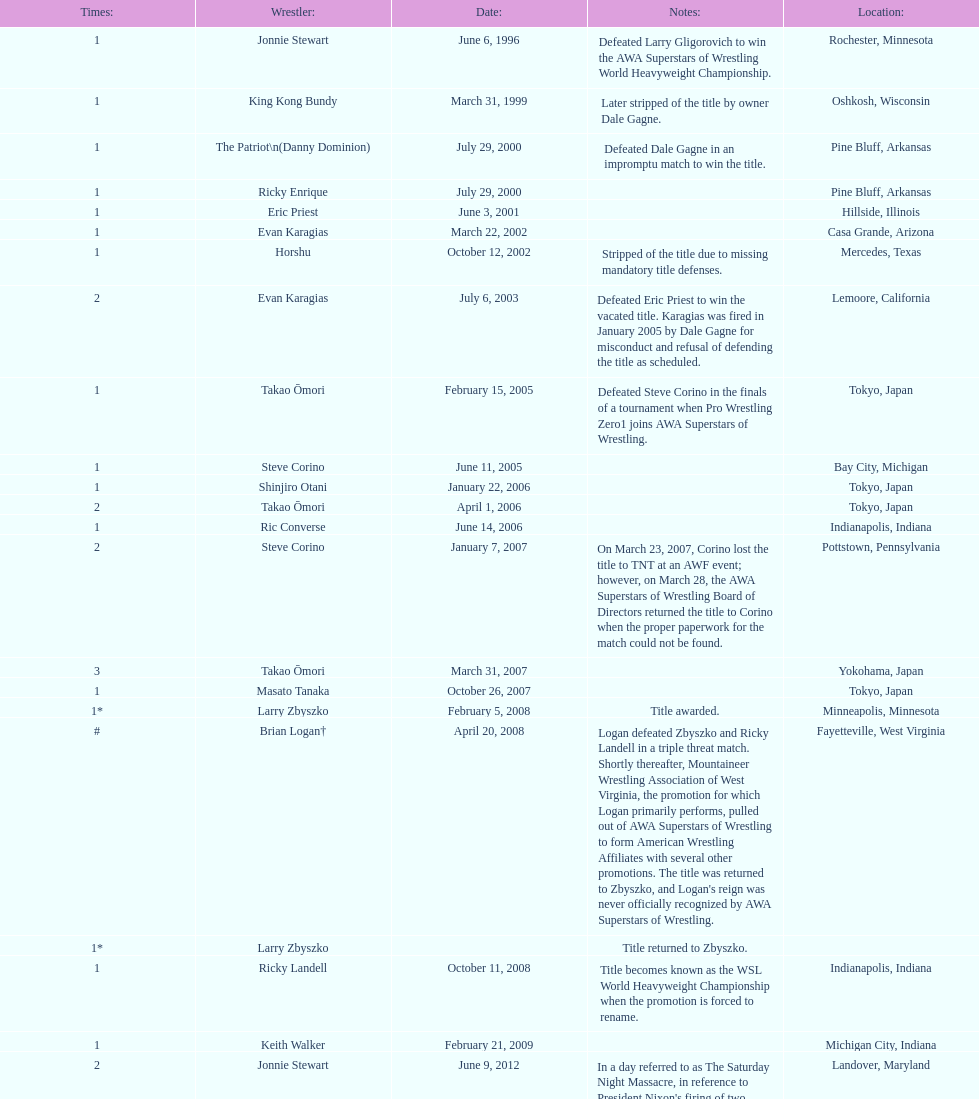The patriot (danny dominion) won the title from what previous holder through an impromptu match? Dale Gagne. 